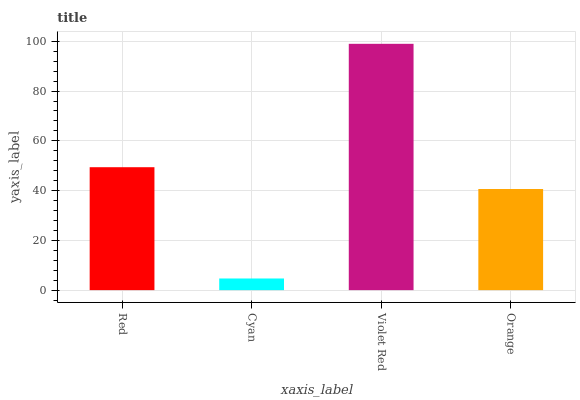Is Cyan the minimum?
Answer yes or no. Yes. Is Violet Red the maximum?
Answer yes or no. Yes. Is Violet Red the minimum?
Answer yes or no. No. Is Cyan the maximum?
Answer yes or no. No. Is Violet Red greater than Cyan?
Answer yes or no. Yes. Is Cyan less than Violet Red?
Answer yes or no. Yes. Is Cyan greater than Violet Red?
Answer yes or no. No. Is Violet Red less than Cyan?
Answer yes or no. No. Is Red the high median?
Answer yes or no. Yes. Is Orange the low median?
Answer yes or no. Yes. Is Violet Red the high median?
Answer yes or no. No. Is Red the low median?
Answer yes or no. No. 